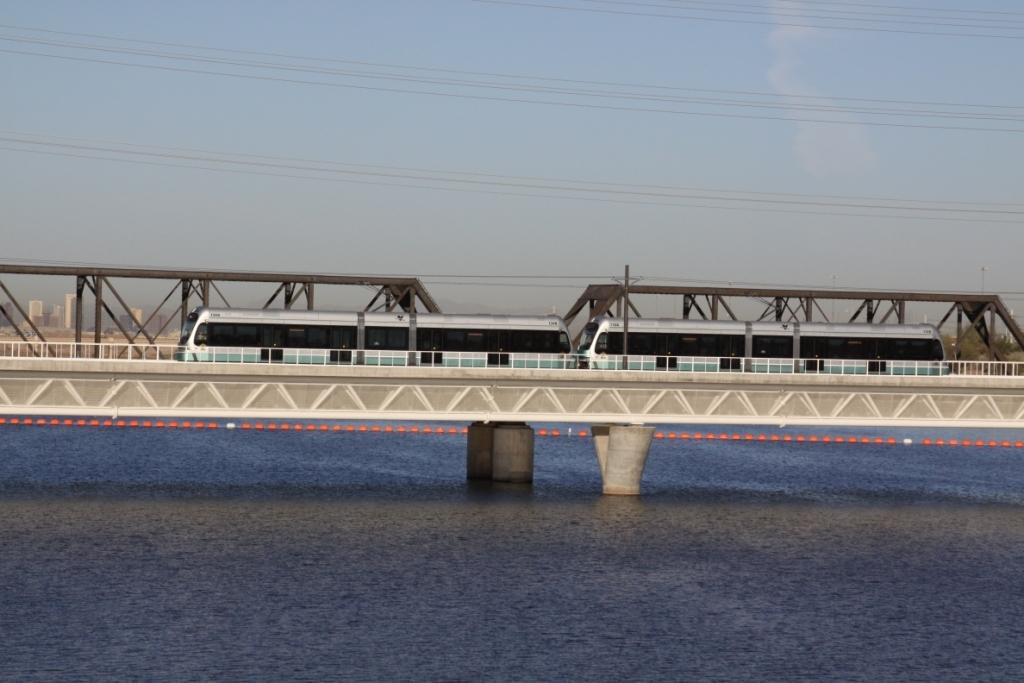What is the main subject of the image? There is a train in the image. Where is the train located? The train is on a bridge. What can be seen near the bridge? There is water visible near the bridge. What is the color of the water? The water has a blue color. What is visible in the background of the image? There is a blue sky in the background of the image. What type of nail is being used to hang a painting in the image? There is no painting or nail present in the image; it features a train on a bridge with water and a blue sky in the background. 